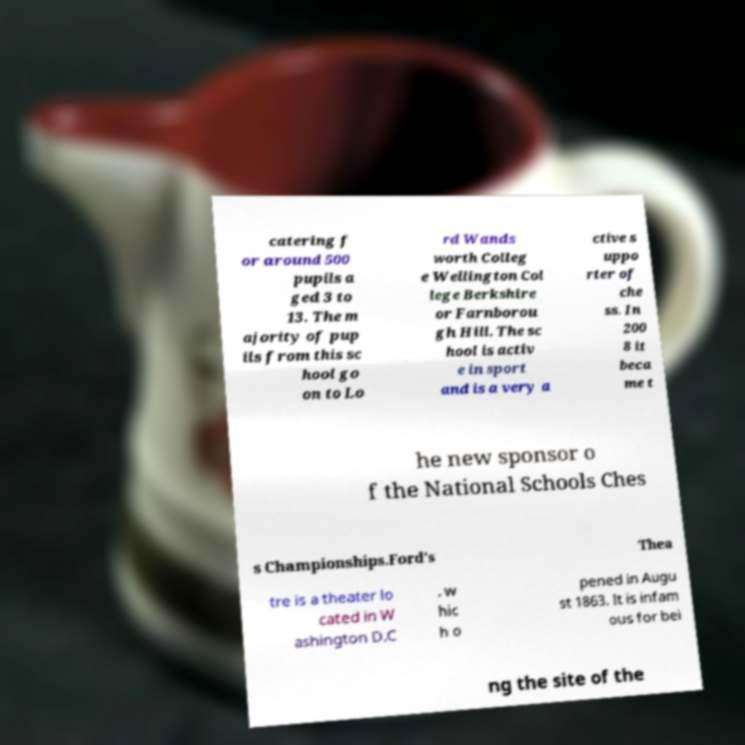Please read and relay the text visible in this image. What does it say? catering f or around 500 pupils a ged 3 to 13. The m ajority of pup ils from this sc hool go on to Lo rd Wands worth Colleg e Wellington Col lege Berkshire or Farnborou gh Hill. The sc hool is activ e in sport and is a very a ctive s uppo rter of che ss. In 200 8 it beca me t he new sponsor o f the National Schools Ches s Championships.Ford's Thea tre is a theater lo cated in W ashington D.C . w hic h o pened in Augu st 1863. It is infam ous for bei ng the site of the 